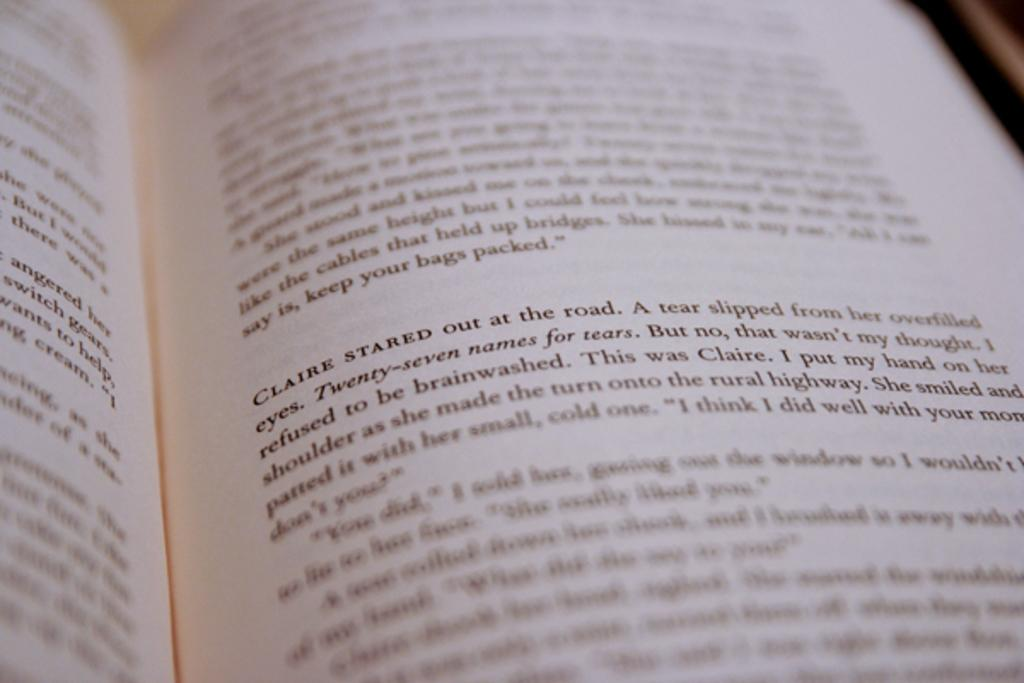<image>
Present a compact description of the photo's key features. A book is open to a page that has a paragraph that begins " Claire stared out at the road." 